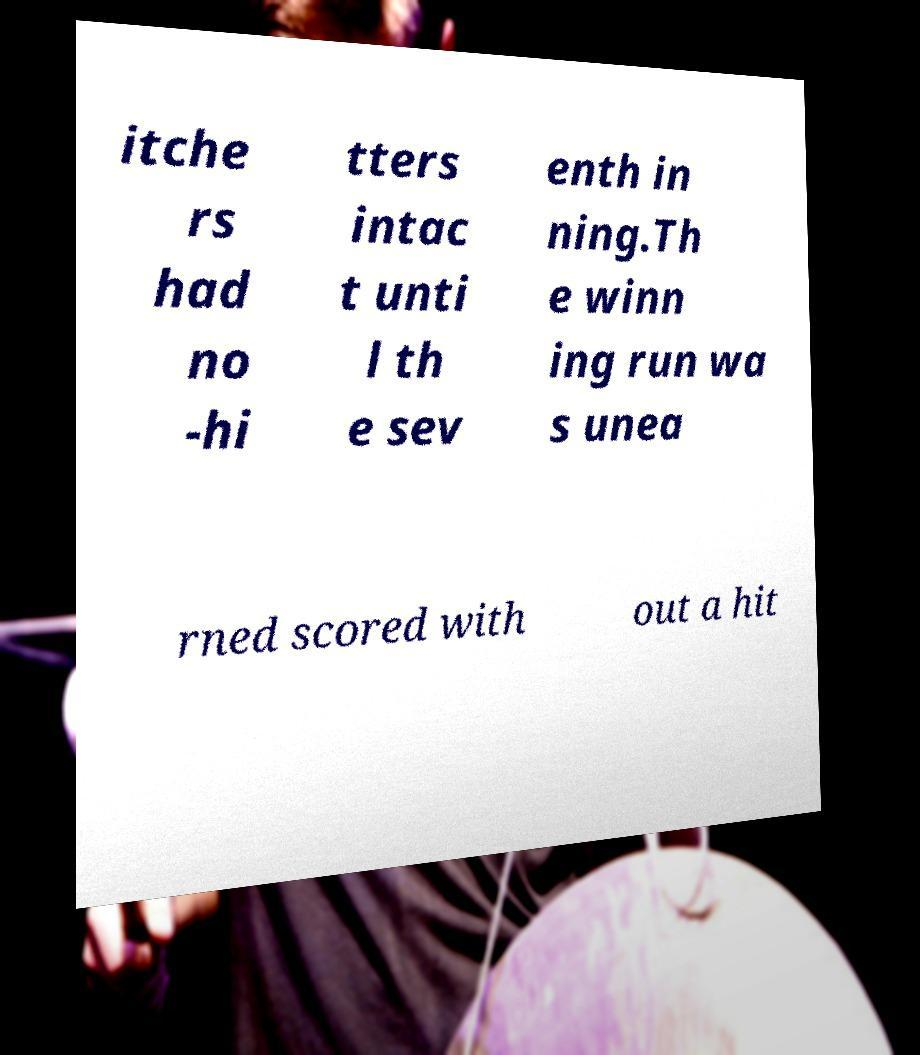Could you extract and type out the text from this image? itche rs had no -hi tters intac t unti l th e sev enth in ning.Th e winn ing run wa s unea rned scored with out a hit 